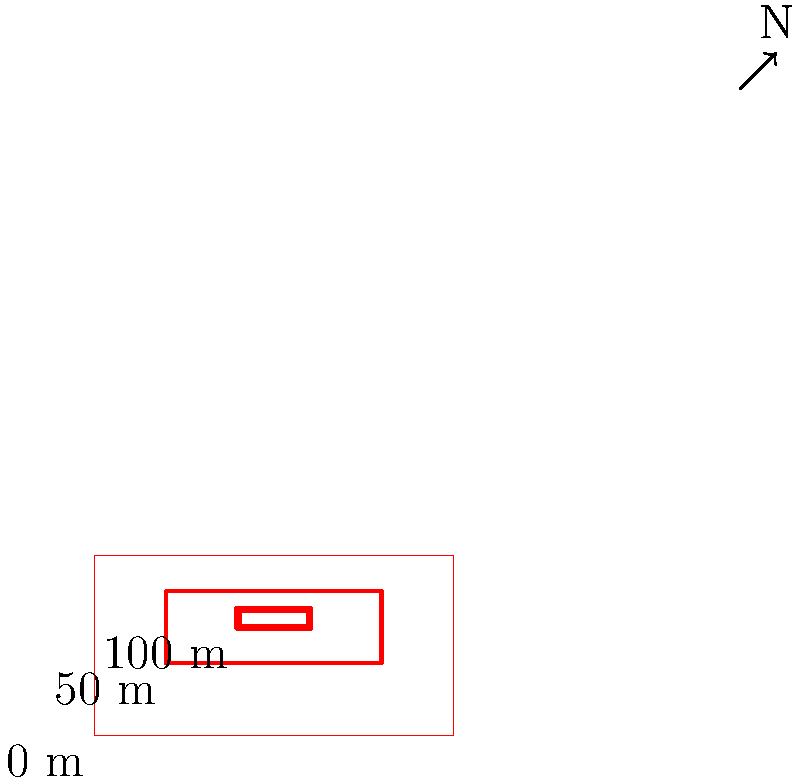Based on the contour map of a remote island, what can you conclude about its topography? How might this influence the island's culture and way of life? To answer this question, let's analyze the contour map step-by-step:

1. Contour lines: The map shows three closed contour lines, each representing a different elevation.

2. Elevation interpretation:
   - The outermost contour (0 m) represents sea level.
   - The middle contour (50 m) indicates a rise in elevation.
   - The innermost contour (100 m) shows the highest point on the island.

3. Island shape: The island appears to be roughly rectangular, with dimensions of about 100 units by 50 units.

4. Topography:
   - The island has a central peak or hill reaching 100 m in elevation.
   - The elevation increases steadily from the coast to the center.
   - There are no sudden cliffs or extremely steep areas, as the contour lines are evenly spaced.

5. Influence on culture and way of life:
   - Coastal areas (0-50 m) may be more suitable for settlements, fishing, and marine-based activities.
   - The central, higher area (50-100 m) could be used for agriculture, especially if it receives more rainfall.
   - The gradual slope might allow for easier movement across the island, potentially fostering a unified culture.
   - The highest point could serve as a lookout or have cultural/spiritual significance.
   - The island's small size and isolation may lead to a close-knit community with unique traditions.

In conclusion, the island has a simple, hill-like topography with a central peak, which could influence settlement patterns, resource utilization, and cultural practices of its inhabitants.
Answer: Hill-like island with central peak; influences settlement, resources, and culture. 